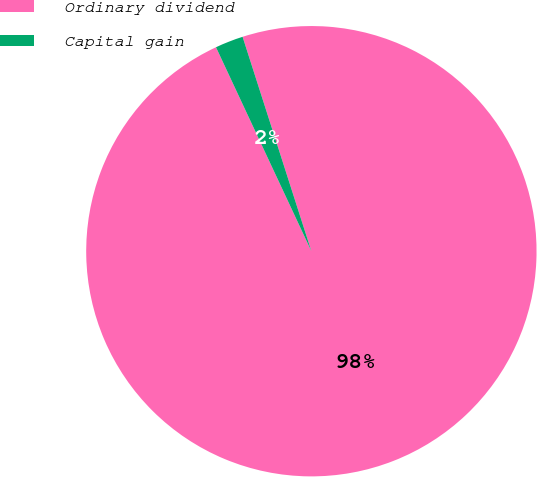Convert chart. <chart><loc_0><loc_0><loc_500><loc_500><pie_chart><fcel>Ordinary dividend<fcel>Capital gain<nl><fcel>97.98%<fcel>2.02%<nl></chart> 